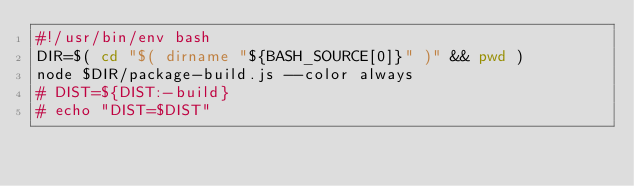<code> <loc_0><loc_0><loc_500><loc_500><_Bash_>#!/usr/bin/env bash
DIR=$( cd "$( dirname "${BASH_SOURCE[0]}" )" && pwd )
node $DIR/package-build.js --color always
# DIST=${DIST:-build}
# echo "DIST=$DIST"</code> 